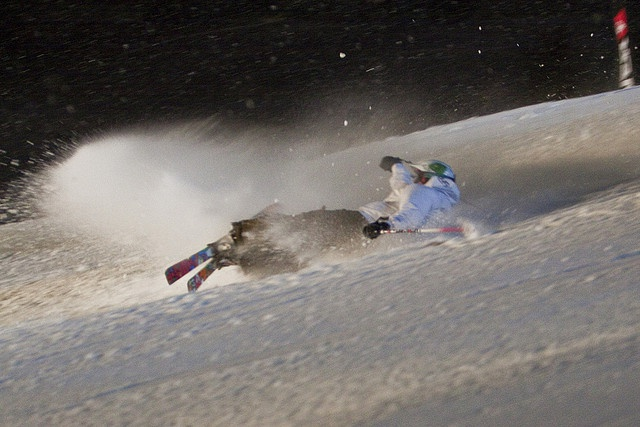Describe the objects in this image and their specific colors. I can see people in black, darkgray, and gray tones and skis in black, gray, maroon, darkgray, and purple tones in this image. 